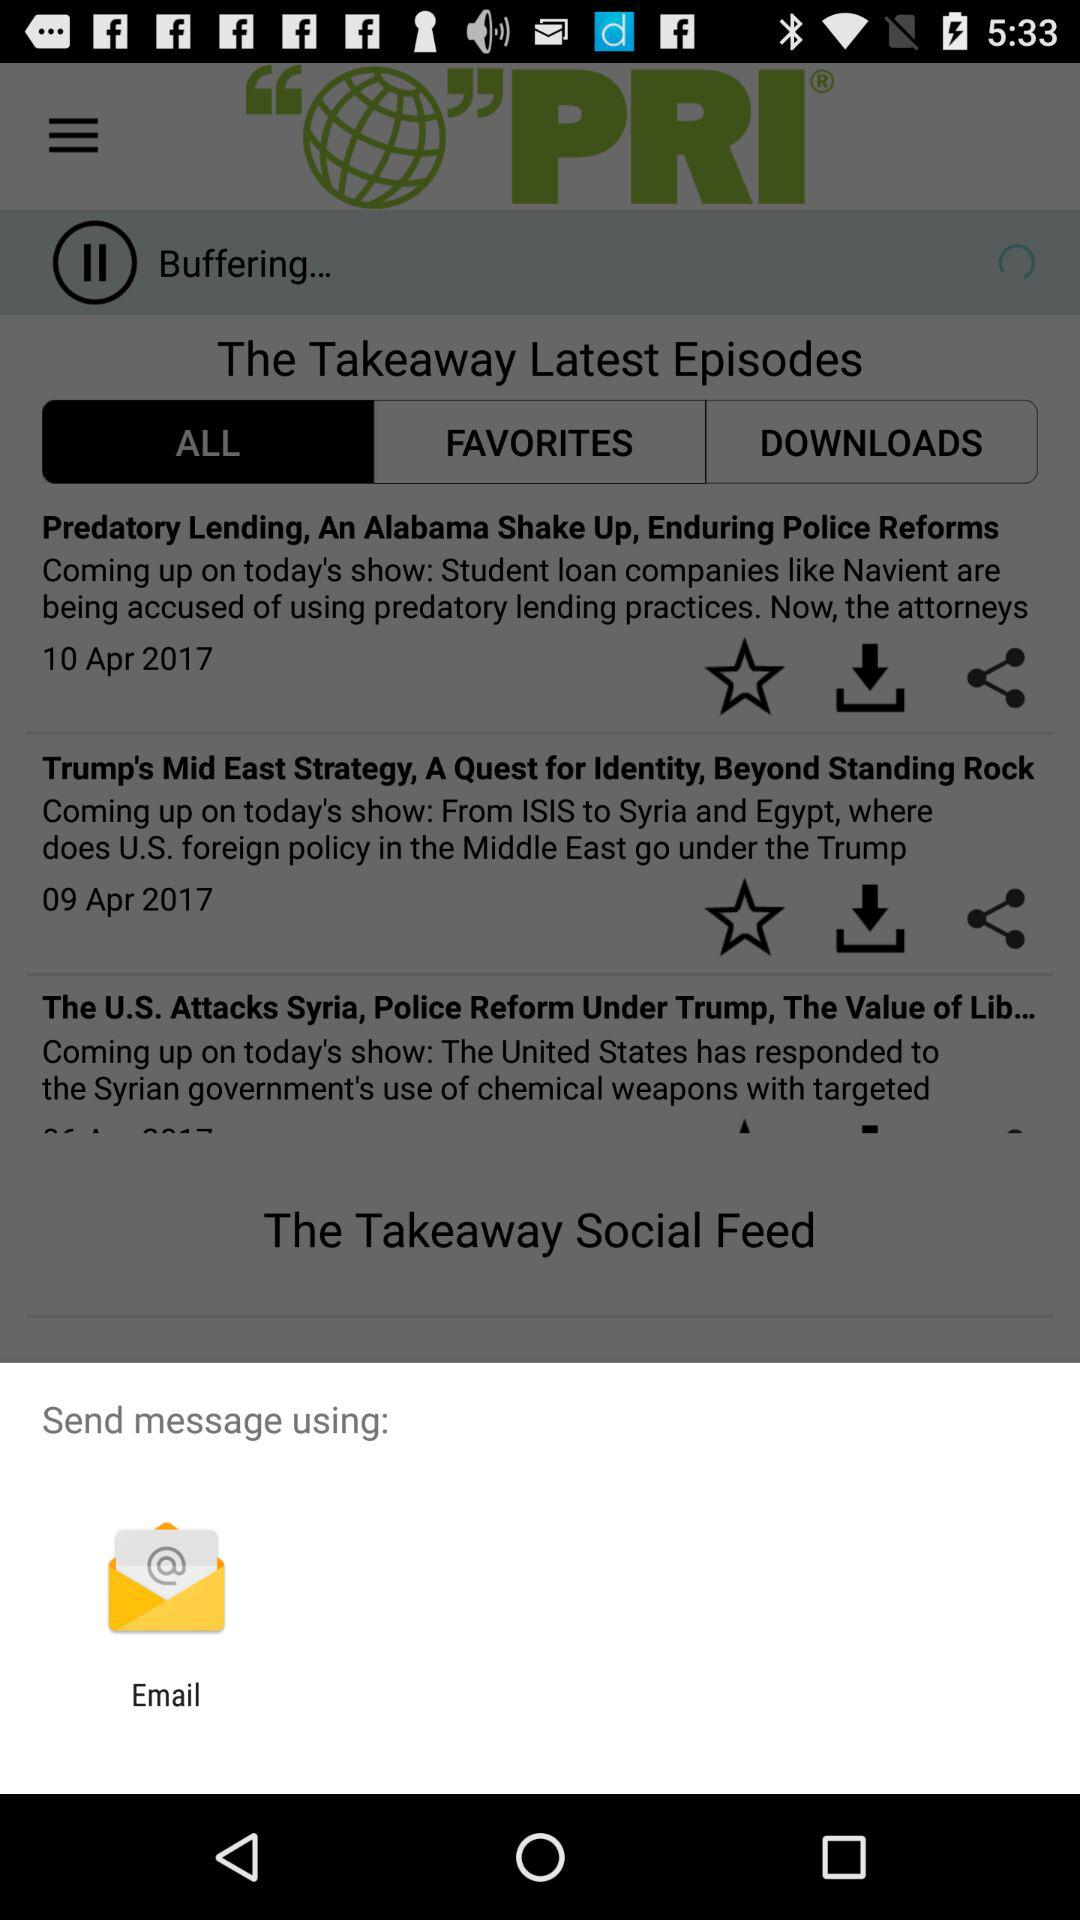Through what app can I share messages? You can share messages through "Email". 